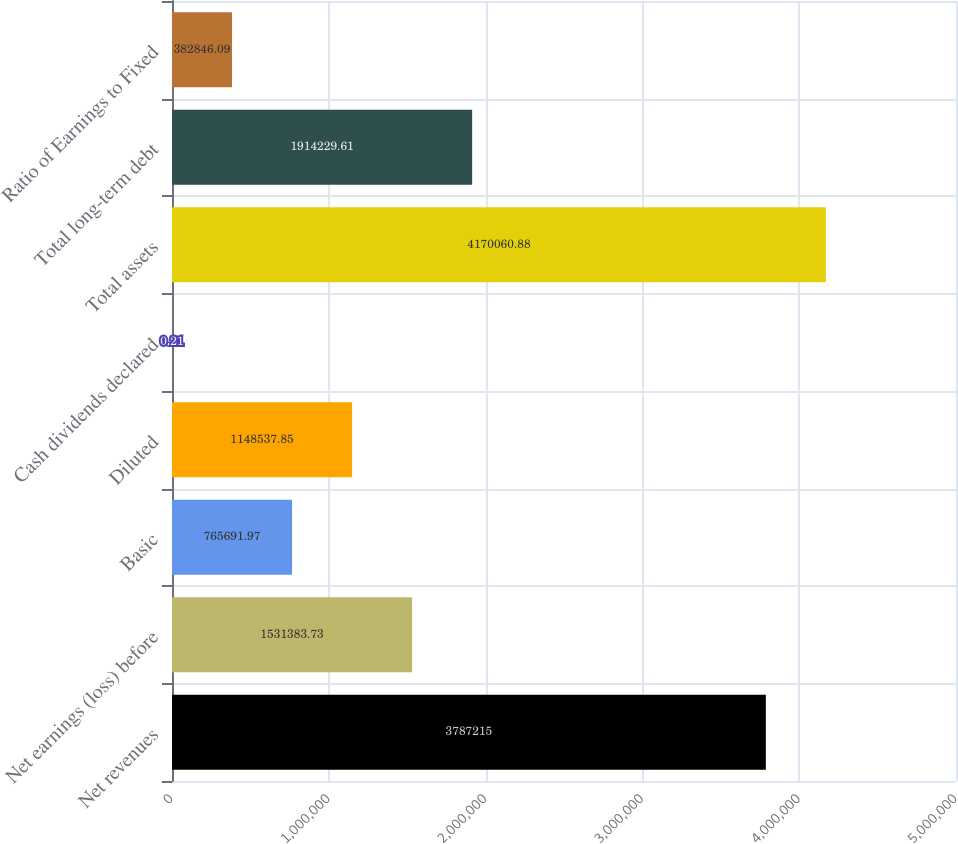<chart> <loc_0><loc_0><loc_500><loc_500><bar_chart><fcel>Net revenues<fcel>Net earnings (loss) before<fcel>Basic<fcel>Diluted<fcel>Cash dividends declared<fcel>Total assets<fcel>Total long-term debt<fcel>Ratio of Earnings to Fixed<nl><fcel>3.78722e+06<fcel>1.53138e+06<fcel>765692<fcel>1.14854e+06<fcel>0.21<fcel>4.17006e+06<fcel>1.91423e+06<fcel>382846<nl></chart> 